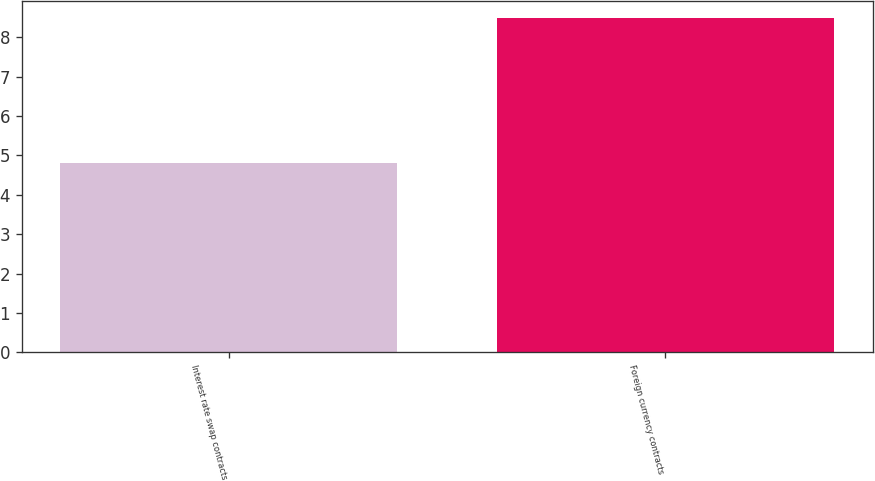Convert chart to OTSL. <chart><loc_0><loc_0><loc_500><loc_500><bar_chart><fcel>Interest rate swap contracts<fcel>Foreign currency contracts<nl><fcel>4.8<fcel>8.5<nl></chart> 